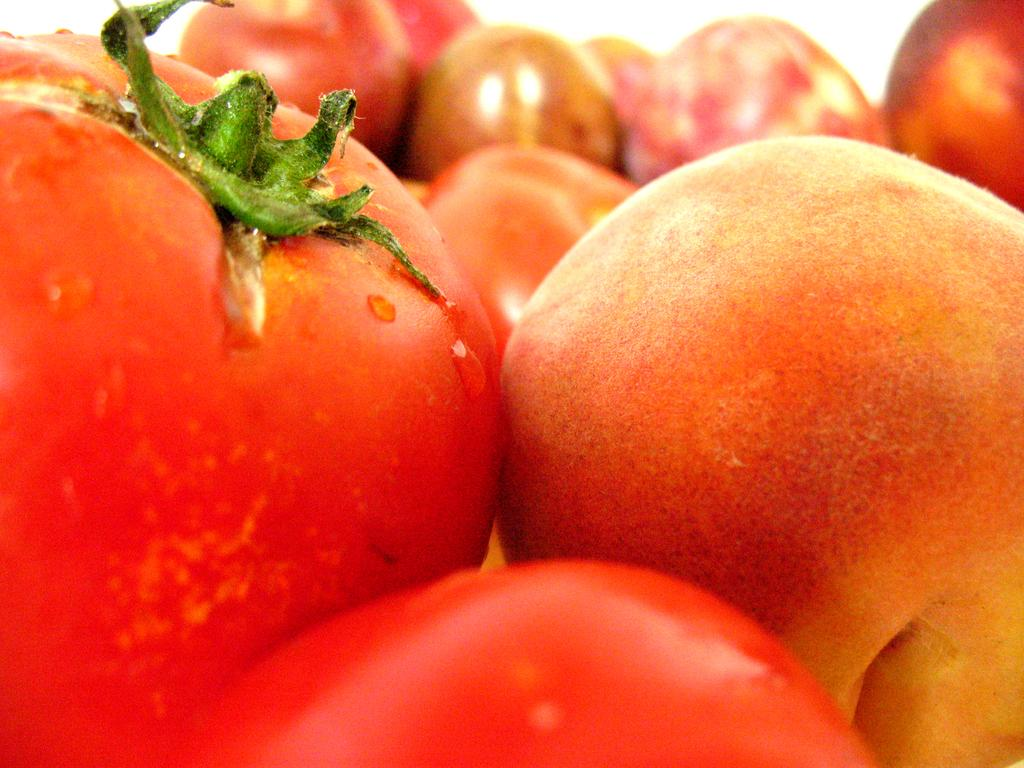What type of fruit or vegetable is present in the image? There are red color tomatoes in the image. What type of footwear can be seen on the tomatoes in the image? There are no footwear or any other objects related to feet present in the image, as it features tomatoes. What type of fruit is growing on top of the tomatoes in the image? There are no other fruits present in the image, as it only features tomatoes. 